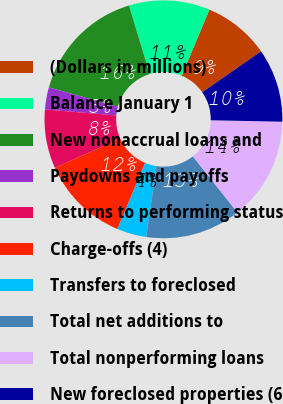<chart> <loc_0><loc_0><loc_500><loc_500><pie_chart><fcel>(Dollars in millions)<fcel>Balance January 1<fcel>New nonaccrual loans and<fcel>Paydowns and payoffs<fcel>Returns to performing status<fcel>Charge-offs (4)<fcel>Transfers to foreclosed<fcel>Total net additions to<fcel>Total nonperforming loans<fcel>New foreclosed properties (6<nl><fcel>9.0%<fcel>11.0%<fcel>16.0%<fcel>3.0%<fcel>8.0%<fcel>12.0%<fcel>4.0%<fcel>13.0%<fcel>14.0%<fcel>10.0%<nl></chart> 